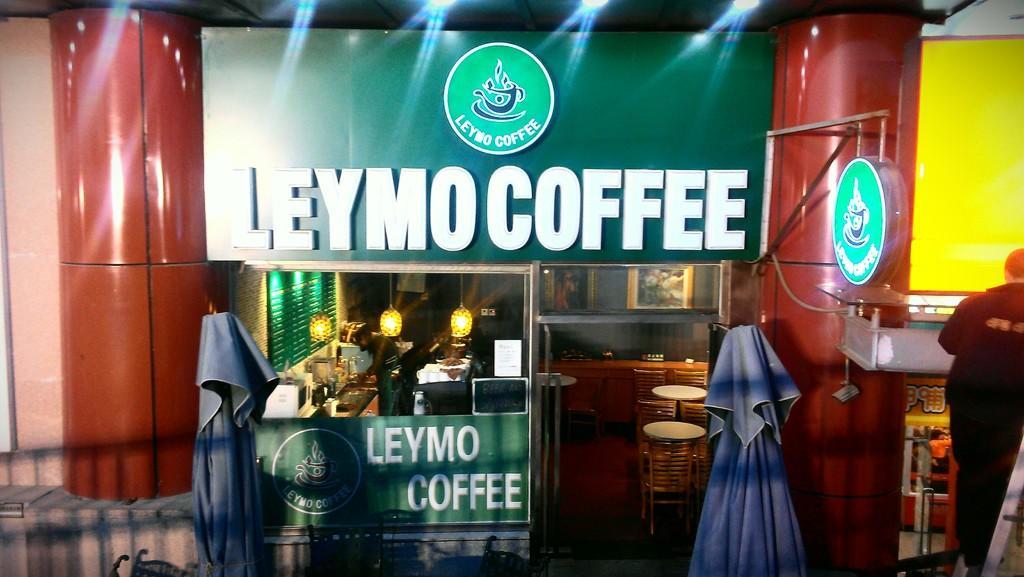How would you summarize this image in a sentence or two? This image is taken indoors. In the middle of the image there is a board with a text on it. There is a room with many things in it. Two men are standing. There are a few empty chairs and tables. There are two curtains. There is a wall and there are two pillars. On the right side of the image a man is standing. There are a few objects. 